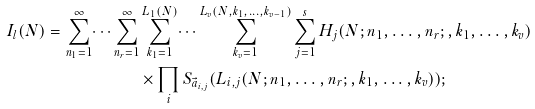<formula> <loc_0><loc_0><loc_500><loc_500>I _ { l } ( N ) = \sum _ { n _ { 1 } = 1 } ^ { \infty } \dots \sum _ { n _ { r } = 1 } ^ { \infty } & \sum _ { k _ { 1 } = 1 } ^ { L _ { 1 } ( N ) } \dots \sum _ { k _ { v } = 1 } ^ { L _ { v } ( N , k _ { 1 } , \dots , k _ { v - 1 } ) } \sum _ { j = 1 } ^ { s } H _ { j } ( N ; n _ { 1 } , \dots , n _ { r } ; , k _ { 1 } , \dots , k _ { v } ) \\ & \times \prod _ { i } S _ { \vec { a } _ { i , j } } ( L _ { i , j } ( N ; n _ { 1 } , \dots , n _ { r } ; , k _ { 1 } , \dots , k _ { v } ) ) ;</formula> 